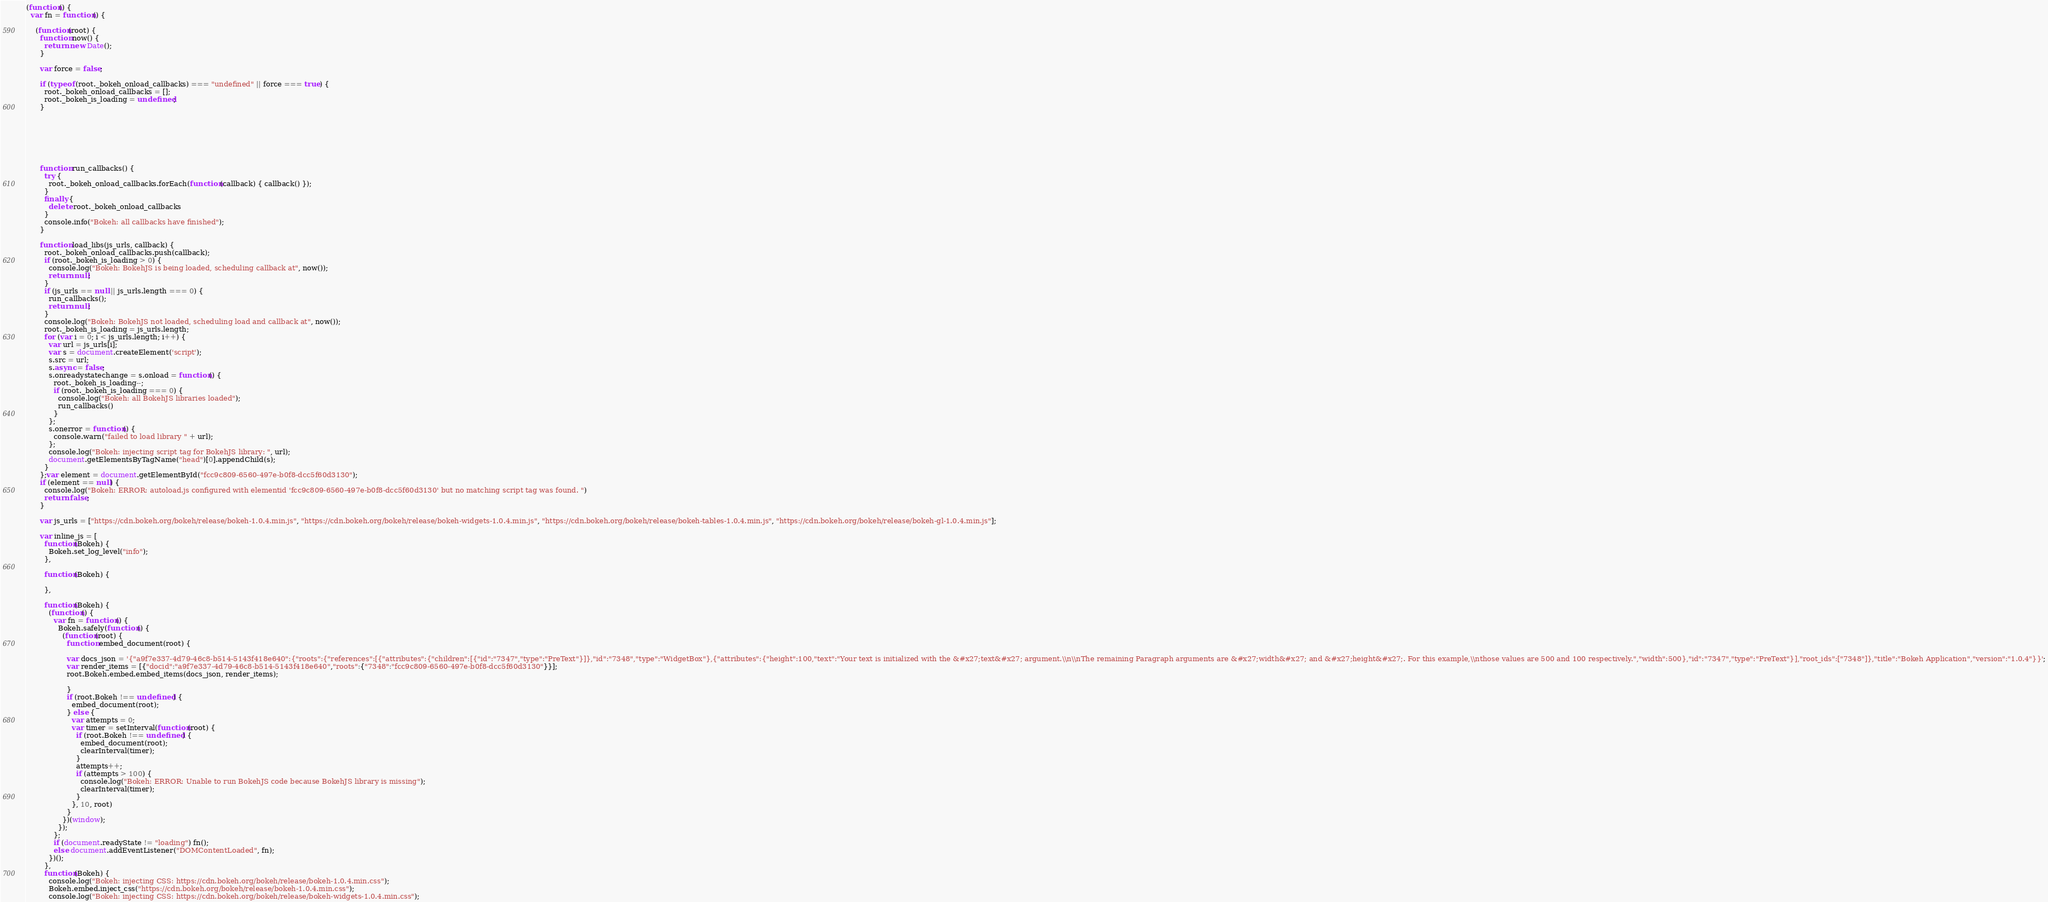<code> <loc_0><loc_0><loc_500><loc_500><_JavaScript_>(function() {
  var fn = function() {
    
    (function(root) {
      function now() {
        return new Date();
      }
    
      var force = false;
    
      if (typeof (root._bokeh_onload_callbacks) === "undefined" || force === true) {
        root._bokeh_onload_callbacks = [];
        root._bokeh_is_loading = undefined;
      }
    
      
      
    
      
      
    
      function run_callbacks() {
        try {
          root._bokeh_onload_callbacks.forEach(function(callback) { callback() });
        }
        finally {
          delete root._bokeh_onload_callbacks
        }
        console.info("Bokeh: all callbacks have finished");
      }
    
      function load_libs(js_urls, callback) {
        root._bokeh_onload_callbacks.push(callback);
        if (root._bokeh_is_loading > 0) {
          console.log("Bokeh: BokehJS is being loaded, scheduling callback at", now());
          return null;
        }
        if (js_urls == null || js_urls.length === 0) {
          run_callbacks();
          return null;
        }
        console.log("Bokeh: BokehJS not loaded, scheduling load and callback at", now());
        root._bokeh_is_loading = js_urls.length;
        for (var i = 0; i < js_urls.length; i++) {
          var url = js_urls[i];
          var s = document.createElement('script');
          s.src = url;
          s.async = false;
          s.onreadystatechange = s.onload = function() {
            root._bokeh_is_loading--;
            if (root._bokeh_is_loading === 0) {
              console.log("Bokeh: all BokehJS libraries loaded");
              run_callbacks()
            }
          };
          s.onerror = function() {
            console.warn("failed to load library " + url);
          };
          console.log("Bokeh: injecting script tag for BokehJS library: ", url);
          document.getElementsByTagName("head")[0].appendChild(s);
        }
      };var element = document.getElementById("fcc9c809-6560-497e-b0f8-dcc5f60d3130");
      if (element == null) {
        console.log("Bokeh: ERROR: autoload.js configured with elementid 'fcc9c809-6560-497e-b0f8-dcc5f60d3130' but no matching script tag was found. ")
        return false;
      }
    
      var js_urls = ["https://cdn.bokeh.org/bokeh/release/bokeh-1.0.4.min.js", "https://cdn.bokeh.org/bokeh/release/bokeh-widgets-1.0.4.min.js", "https://cdn.bokeh.org/bokeh/release/bokeh-tables-1.0.4.min.js", "https://cdn.bokeh.org/bokeh/release/bokeh-gl-1.0.4.min.js"];
    
      var inline_js = [
        function(Bokeh) {
          Bokeh.set_log_level("info");
        },
        
        function(Bokeh) {
          
        },
        
        function(Bokeh) {
          (function() {
            var fn = function() {
              Bokeh.safely(function() {
                (function(root) {
                  function embed_document(root) {
                    
                  var docs_json = '{"a9f7e337-4d79-46c8-b514-5143f418e640":{"roots":{"references":[{"attributes":{"children":[{"id":"7347","type":"PreText"}]},"id":"7348","type":"WidgetBox"},{"attributes":{"height":100,"text":"Your text is initialized with the &#x27;text&#x27; argument.\\n\\nThe remaining Paragraph arguments are &#x27;width&#x27; and &#x27;height&#x27;. For this example,\\nthose values are 500 and 100 respectively.","width":500},"id":"7347","type":"PreText"}],"root_ids":["7348"]},"title":"Bokeh Application","version":"1.0.4"}}';
                  var render_items = [{"docid":"a9f7e337-4d79-46c8-b514-5143f418e640","roots":{"7348":"fcc9c809-6560-497e-b0f8-dcc5f60d3130"}}];
                  root.Bokeh.embed.embed_items(docs_json, render_items);
                
                  }
                  if (root.Bokeh !== undefined) {
                    embed_document(root);
                  } else {
                    var attempts = 0;
                    var timer = setInterval(function(root) {
                      if (root.Bokeh !== undefined) {
                        embed_document(root);
                        clearInterval(timer);
                      }
                      attempts++;
                      if (attempts > 100) {
                        console.log("Bokeh: ERROR: Unable to run BokehJS code because BokehJS library is missing");
                        clearInterval(timer);
                      }
                    }, 10, root)
                  }
                })(window);
              });
            };
            if (document.readyState != "loading") fn();
            else document.addEventListener("DOMContentLoaded", fn);
          })();
        },
        function(Bokeh) {
          console.log("Bokeh: injecting CSS: https://cdn.bokeh.org/bokeh/release/bokeh-1.0.4.min.css");
          Bokeh.embed.inject_css("https://cdn.bokeh.org/bokeh/release/bokeh-1.0.4.min.css");
          console.log("Bokeh: injecting CSS: https://cdn.bokeh.org/bokeh/release/bokeh-widgets-1.0.4.min.css");</code> 